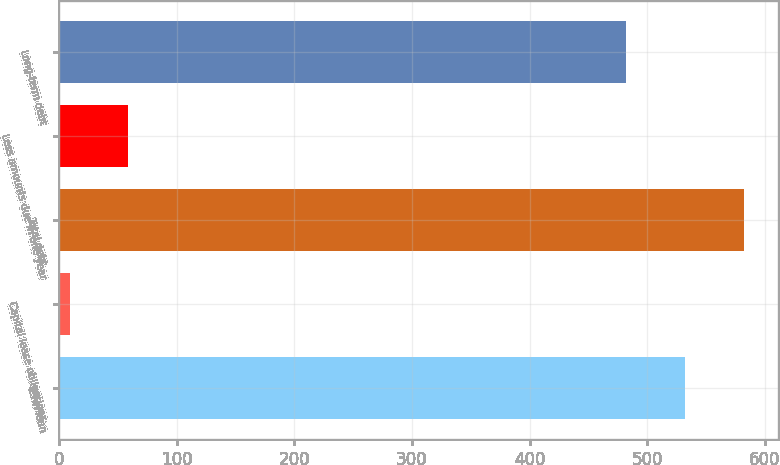Convert chart to OTSL. <chart><loc_0><loc_0><loc_500><loc_500><bar_chart><fcel>Term loan<fcel>Capital lease obligations<fcel>Total debt<fcel>Less amounts due in one year<fcel>Long-term debt<nl><fcel>532<fcel>9<fcel>582<fcel>59<fcel>482<nl></chart> 